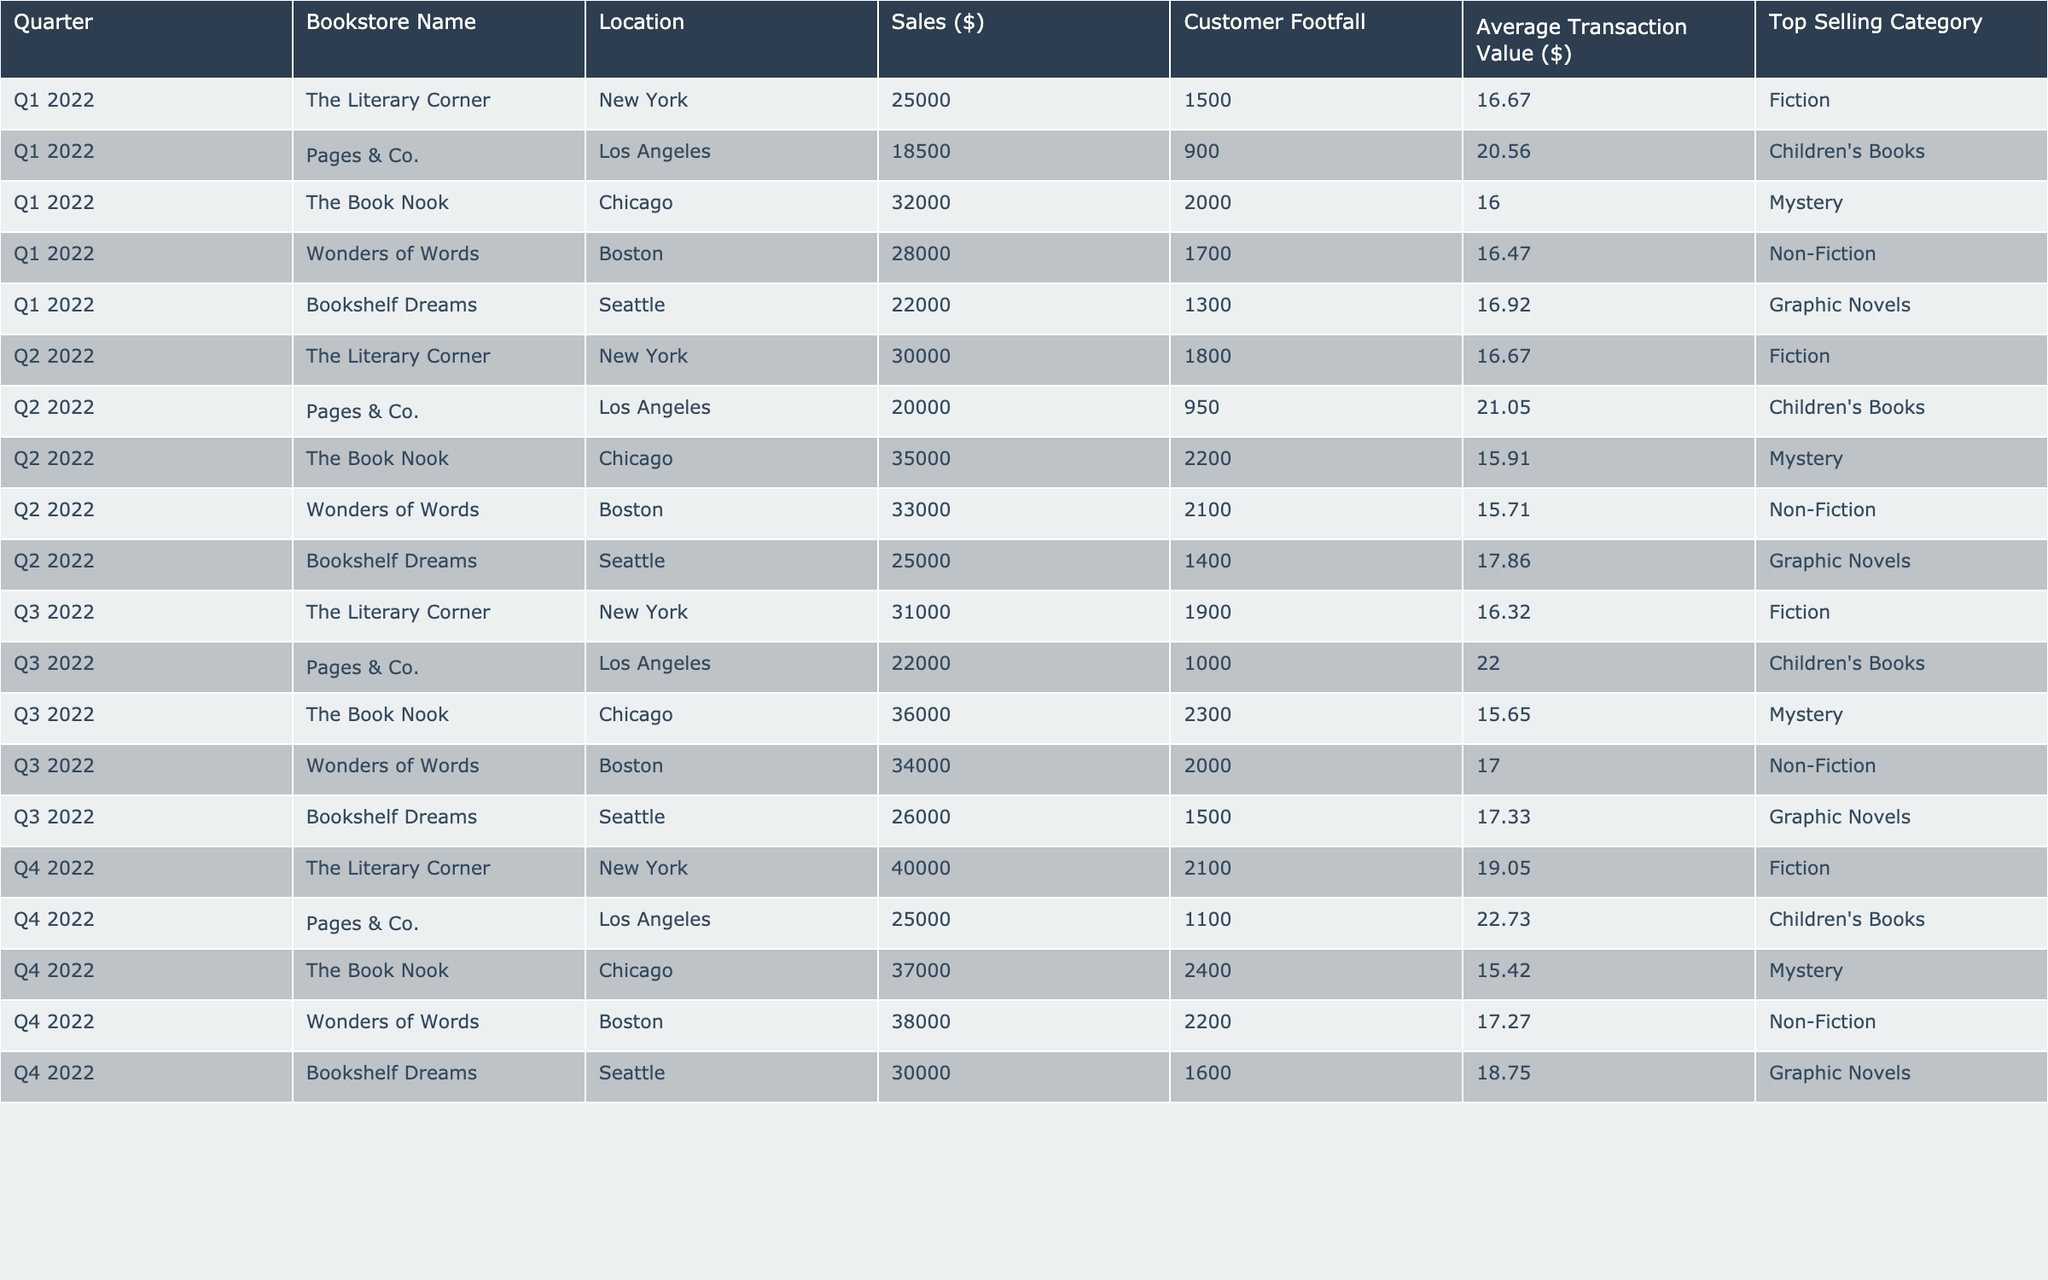What was the total sales for The Book Nook in 2022? The sales data for The Book Nook shows: Q1 - 32,000; Q2 - 35,000; Q3 - 36,000; Q4 - 37,000. Adding these gives 32,000 + 35,000 + 36,000 + 37,000 = 140,000.
Answer: 140,000 Which bookstore had the highest sales in Q4 2022? In Q4 2022, the sales for each bookstore were: The Literary Corner - 40,000, Pages & Co. - 25,000, The Book Nook - 37,000, Wonders of Words - 38,000, and Bookshelf Dreams - 30,000. The highest sales were from The Literary Corner at 40,000.
Answer: The Literary Corner What was the average sales per quarter for Pages & Co. in 2022? The sales for Pages & Co. were: Q1 - 18,500, Q2 - 20,000, Q3 - 22,000, Q4 - 25,000. The total is 18,500 + 20,000 + 22,000 + 25,000 = 85,500. The average is 85,500 / 4 = 21,375.
Answer: 21,375 Did the customer footfall for Wonders of Words increase from Q1 to Q4 2022? Customer footfall for Q1 was 1,700, and for Q4 it was 2,200. Since 2,200 is greater than 1,700, it indicates that customer footfall did increase from Q1 to Q4.
Answer: Yes Which category had the lowest average transaction value in Q3 2022? The average transaction values in Q3 2022 were: The Literary Corner - 16.32, Pages & Co. - 22.00, The Book Nook - 15.65, Wonders of Words - 17.00, and Bookshelf Dreams - 17.33. The lowest is from The Book Nook at 15.65.
Answer: The Book Nook What was the sales growth from Q1 to Q2 2022 for The Literary Corner? Sales for The Literary Corner in Q1 was 25,000 and in Q2 it was 30,000. The growth is calculated by (30,000 - 25,000) = 5,000. To express as a percentage, (5,000 / 25,000) * 100 = 20%.
Answer: 20% What percentage of total sales in Q2 2022 came from The Book Nook? The sales for all bookstores in Q2 2022 totaled: 30,000 (The Literary Corner) + 20,000 (Pages & Co.) + 35,000 (The Book Nook) + 33,000 (Wonders of Words) + 25,000 (Bookshelf Dreams) = 143,000. The Book Nook's sales were 35,000. The percentage is (35,000 / 143,000) * 100 = 24.48%.
Answer: 24.48% Which bookstore consistently had the highest sales each quarter in 2022? Evaluating the quarterly sales, The Literary Corner had sales of 25,000 in Q1, 30,000 in Q2, 31,000 in Q3, and 40,000 in Q4. There was no other bookstore that surpassed its sales in any quarter.
Answer: The Literary Corner What is the total customer footfall for Bookshelf Dreams across all quarters in 2022? The customer footfalls were: Q1 - 1,300, Q2 - 1,400, Q3 - 1,500, Q4 - 1,600. Adding these gives 1,300 + 1,400 + 1,500 + 1,600 = 5,800.
Answer: 5,800 Was the average transaction value for Children's Books in Q3 higher than $20? The average transaction value for Pages & Co. selling Children's Books in Q3 is 22.00, which is indeed higher than $20.
Answer: Yes What was the difference in sales between the highest and lowest selling bookstore in Q4 2022? The highest selling bookstore in Q4 2022 was The Literary Corner with 40,000, and the lowest was Pages & Co. with 25,000. The difference is 40,000 - 25,000 = 15,000.
Answer: 15,000 